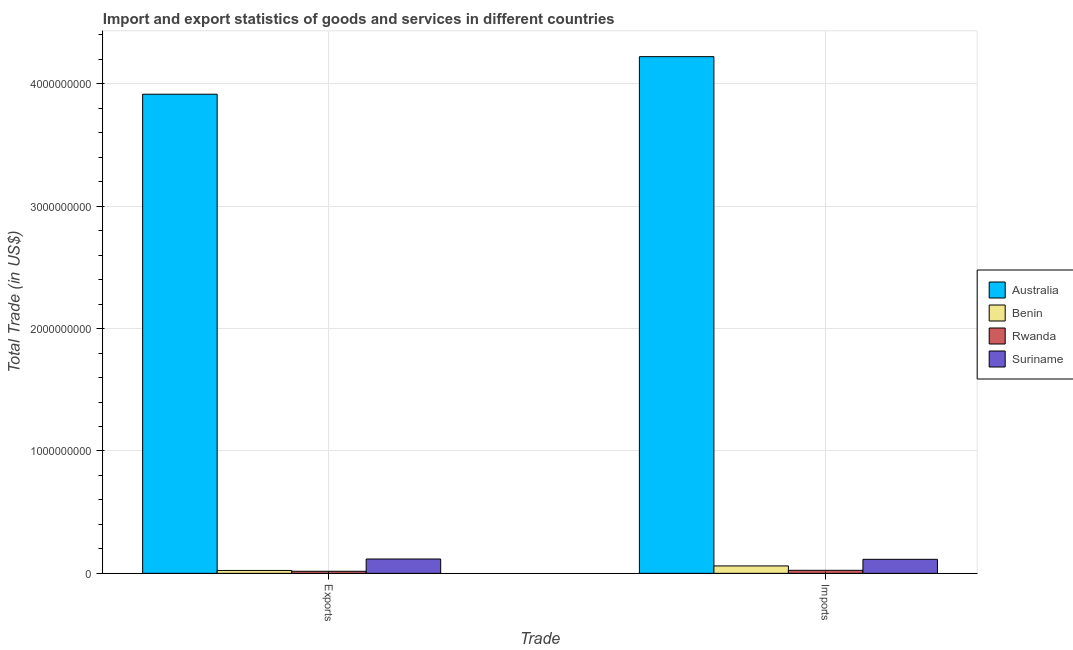How many groups of bars are there?
Keep it short and to the point. 2. Are the number of bars per tick equal to the number of legend labels?
Give a very brief answer. Yes. Are the number of bars on each tick of the X-axis equal?
Make the answer very short. Yes. How many bars are there on the 1st tick from the right?
Your answer should be compact. 4. What is the label of the 1st group of bars from the left?
Your response must be concise. Exports. What is the imports of goods and services in Australia?
Make the answer very short. 4.22e+09. Across all countries, what is the maximum export of goods and services?
Provide a succinct answer. 3.92e+09. Across all countries, what is the minimum export of goods and services?
Provide a short and direct response. 1.68e+07. In which country was the imports of goods and services maximum?
Provide a short and direct response. Australia. In which country was the imports of goods and services minimum?
Your answer should be very brief. Rwanda. What is the total export of goods and services in the graph?
Your answer should be compact. 4.07e+09. What is the difference between the export of goods and services in Australia and that in Rwanda?
Keep it short and to the point. 3.90e+09. What is the difference between the imports of goods and services in Benin and the export of goods and services in Suriname?
Provide a short and direct response. -5.66e+07. What is the average export of goods and services per country?
Keep it short and to the point. 1.02e+09. What is the difference between the imports of goods and services and export of goods and services in Australia?
Your answer should be very brief. 3.07e+08. In how many countries, is the export of goods and services greater than 1200000000 US$?
Ensure brevity in your answer.  1. What is the ratio of the imports of goods and services in Australia to that in Benin?
Your response must be concise. 69.73. In how many countries, is the export of goods and services greater than the average export of goods and services taken over all countries?
Your answer should be very brief. 1. What does the 4th bar from the left in Exports represents?
Keep it short and to the point. Suriname. What does the 1st bar from the right in Imports represents?
Offer a very short reply. Suriname. How many bars are there?
Provide a short and direct response. 8. How many countries are there in the graph?
Give a very brief answer. 4. How many legend labels are there?
Your response must be concise. 4. How are the legend labels stacked?
Make the answer very short. Vertical. What is the title of the graph?
Provide a succinct answer. Import and export statistics of goods and services in different countries. Does "Afghanistan" appear as one of the legend labels in the graph?
Provide a short and direct response. No. What is the label or title of the X-axis?
Your answer should be very brief. Trade. What is the label or title of the Y-axis?
Ensure brevity in your answer.  Total Trade (in US$). What is the Total Trade (in US$) in Australia in Exports?
Provide a short and direct response. 3.92e+09. What is the Total Trade (in US$) in Benin in Exports?
Make the answer very short. 2.35e+07. What is the Total Trade (in US$) in Rwanda in Exports?
Provide a short and direct response. 1.68e+07. What is the Total Trade (in US$) of Suriname in Exports?
Your answer should be compact. 1.17e+08. What is the Total Trade (in US$) of Australia in Imports?
Give a very brief answer. 4.22e+09. What is the Total Trade (in US$) in Benin in Imports?
Keep it short and to the point. 6.05e+07. What is the Total Trade (in US$) in Rwanda in Imports?
Keep it short and to the point. 2.46e+07. What is the Total Trade (in US$) of Suriname in Imports?
Offer a terse response. 1.14e+08. Across all Trade, what is the maximum Total Trade (in US$) of Australia?
Provide a succinct answer. 4.22e+09. Across all Trade, what is the maximum Total Trade (in US$) in Benin?
Keep it short and to the point. 6.05e+07. Across all Trade, what is the maximum Total Trade (in US$) in Rwanda?
Give a very brief answer. 2.46e+07. Across all Trade, what is the maximum Total Trade (in US$) of Suriname?
Ensure brevity in your answer.  1.17e+08. Across all Trade, what is the minimum Total Trade (in US$) of Australia?
Make the answer very short. 3.92e+09. Across all Trade, what is the minimum Total Trade (in US$) in Benin?
Make the answer very short. 2.35e+07. Across all Trade, what is the minimum Total Trade (in US$) of Rwanda?
Offer a terse response. 1.68e+07. Across all Trade, what is the minimum Total Trade (in US$) in Suriname?
Offer a terse response. 1.14e+08. What is the total Total Trade (in US$) in Australia in the graph?
Provide a short and direct response. 8.14e+09. What is the total Total Trade (in US$) of Benin in the graph?
Make the answer very short. 8.40e+07. What is the total Total Trade (in US$) in Rwanda in the graph?
Provide a short and direct response. 4.14e+07. What is the total Total Trade (in US$) of Suriname in the graph?
Provide a succinct answer. 2.32e+08. What is the difference between the Total Trade (in US$) in Australia in Exports and that in Imports?
Make the answer very short. -3.07e+08. What is the difference between the Total Trade (in US$) of Benin in Exports and that in Imports?
Keep it short and to the point. -3.71e+07. What is the difference between the Total Trade (in US$) in Rwanda in Exports and that in Imports?
Ensure brevity in your answer.  -7.82e+06. What is the difference between the Total Trade (in US$) in Suriname in Exports and that in Imports?
Your response must be concise. 2.65e+06. What is the difference between the Total Trade (in US$) in Australia in Exports and the Total Trade (in US$) in Benin in Imports?
Your response must be concise. 3.85e+09. What is the difference between the Total Trade (in US$) in Australia in Exports and the Total Trade (in US$) in Rwanda in Imports?
Your answer should be compact. 3.89e+09. What is the difference between the Total Trade (in US$) in Australia in Exports and the Total Trade (in US$) in Suriname in Imports?
Your answer should be compact. 3.80e+09. What is the difference between the Total Trade (in US$) in Benin in Exports and the Total Trade (in US$) in Rwanda in Imports?
Keep it short and to the point. -1.12e+06. What is the difference between the Total Trade (in US$) of Benin in Exports and the Total Trade (in US$) of Suriname in Imports?
Offer a very short reply. -9.10e+07. What is the difference between the Total Trade (in US$) in Rwanda in Exports and the Total Trade (in US$) in Suriname in Imports?
Give a very brief answer. -9.77e+07. What is the average Total Trade (in US$) in Australia per Trade?
Your response must be concise. 4.07e+09. What is the average Total Trade (in US$) in Benin per Trade?
Ensure brevity in your answer.  4.20e+07. What is the average Total Trade (in US$) of Rwanda per Trade?
Ensure brevity in your answer.  2.07e+07. What is the average Total Trade (in US$) of Suriname per Trade?
Keep it short and to the point. 1.16e+08. What is the difference between the Total Trade (in US$) of Australia and Total Trade (in US$) of Benin in Exports?
Your response must be concise. 3.89e+09. What is the difference between the Total Trade (in US$) in Australia and Total Trade (in US$) in Rwanda in Exports?
Keep it short and to the point. 3.90e+09. What is the difference between the Total Trade (in US$) in Australia and Total Trade (in US$) in Suriname in Exports?
Your answer should be very brief. 3.80e+09. What is the difference between the Total Trade (in US$) of Benin and Total Trade (in US$) of Rwanda in Exports?
Provide a short and direct response. 6.70e+06. What is the difference between the Total Trade (in US$) of Benin and Total Trade (in US$) of Suriname in Exports?
Offer a very short reply. -9.36e+07. What is the difference between the Total Trade (in US$) of Rwanda and Total Trade (in US$) of Suriname in Exports?
Give a very brief answer. -1.00e+08. What is the difference between the Total Trade (in US$) in Australia and Total Trade (in US$) in Benin in Imports?
Provide a short and direct response. 4.16e+09. What is the difference between the Total Trade (in US$) in Australia and Total Trade (in US$) in Rwanda in Imports?
Provide a succinct answer. 4.20e+09. What is the difference between the Total Trade (in US$) in Australia and Total Trade (in US$) in Suriname in Imports?
Keep it short and to the point. 4.11e+09. What is the difference between the Total Trade (in US$) in Benin and Total Trade (in US$) in Rwanda in Imports?
Your answer should be very brief. 3.60e+07. What is the difference between the Total Trade (in US$) in Benin and Total Trade (in US$) in Suriname in Imports?
Your response must be concise. -5.39e+07. What is the difference between the Total Trade (in US$) in Rwanda and Total Trade (in US$) in Suriname in Imports?
Offer a very short reply. -8.99e+07. What is the ratio of the Total Trade (in US$) in Australia in Exports to that in Imports?
Your response must be concise. 0.93. What is the ratio of the Total Trade (in US$) of Benin in Exports to that in Imports?
Keep it short and to the point. 0.39. What is the ratio of the Total Trade (in US$) of Rwanda in Exports to that in Imports?
Provide a succinct answer. 0.68. What is the ratio of the Total Trade (in US$) of Suriname in Exports to that in Imports?
Your answer should be very brief. 1.02. What is the difference between the highest and the second highest Total Trade (in US$) of Australia?
Offer a very short reply. 3.07e+08. What is the difference between the highest and the second highest Total Trade (in US$) in Benin?
Ensure brevity in your answer.  3.71e+07. What is the difference between the highest and the second highest Total Trade (in US$) of Rwanda?
Offer a terse response. 7.82e+06. What is the difference between the highest and the second highest Total Trade (in US$) of Suriname?
Your response must be concise. 2.65e+06. What is the difference between the highest and the lowest Total Trade (in US$) of Australia?
Offer a very short reply. 3.07e+08. What is the difference between the highest and the lowest Total Trade (in US$) in Benin?
Your answer should be very brief. 3.71e+07. What is the difference between the highest and the lowest Total Trade (in US$) of Rwanda?
Give a very brief answer. 7.82e+06. What is the difference between the highest and the lowest Total Trade (in US$) of Suriname?
Make the answer very short. 2.65e+06. 